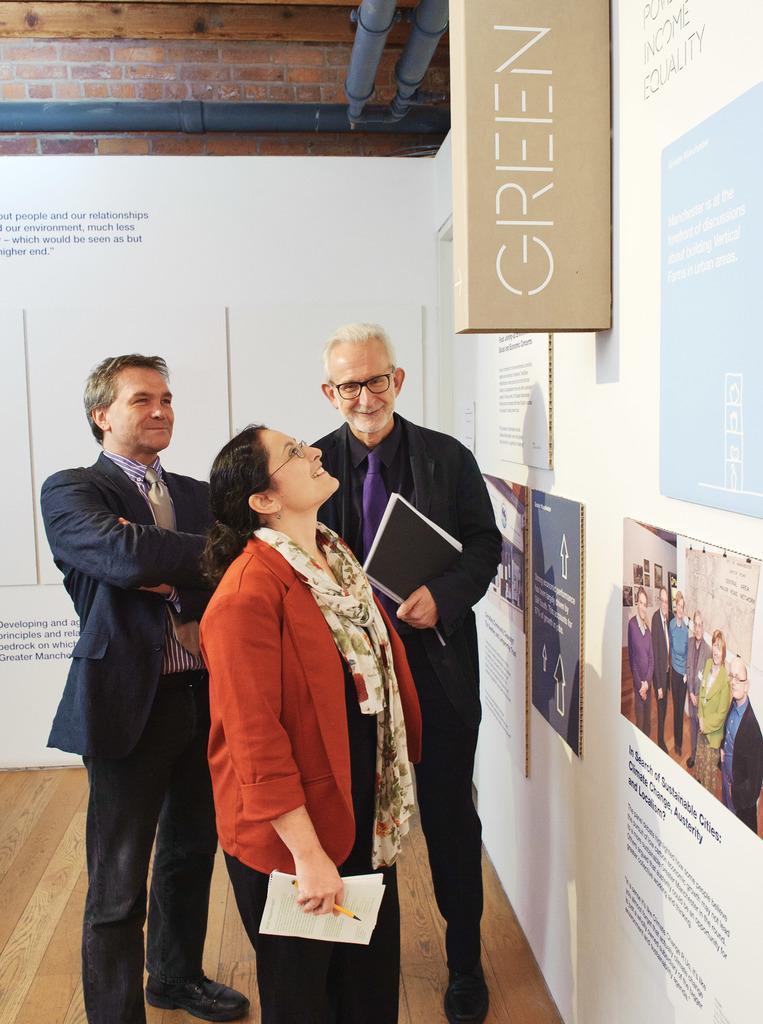Could you give a brief overview of what you see in this image? In this image in the center there are persons standing and smiling and there are boards on the wall with some text written on it. On the top there are pipes. 